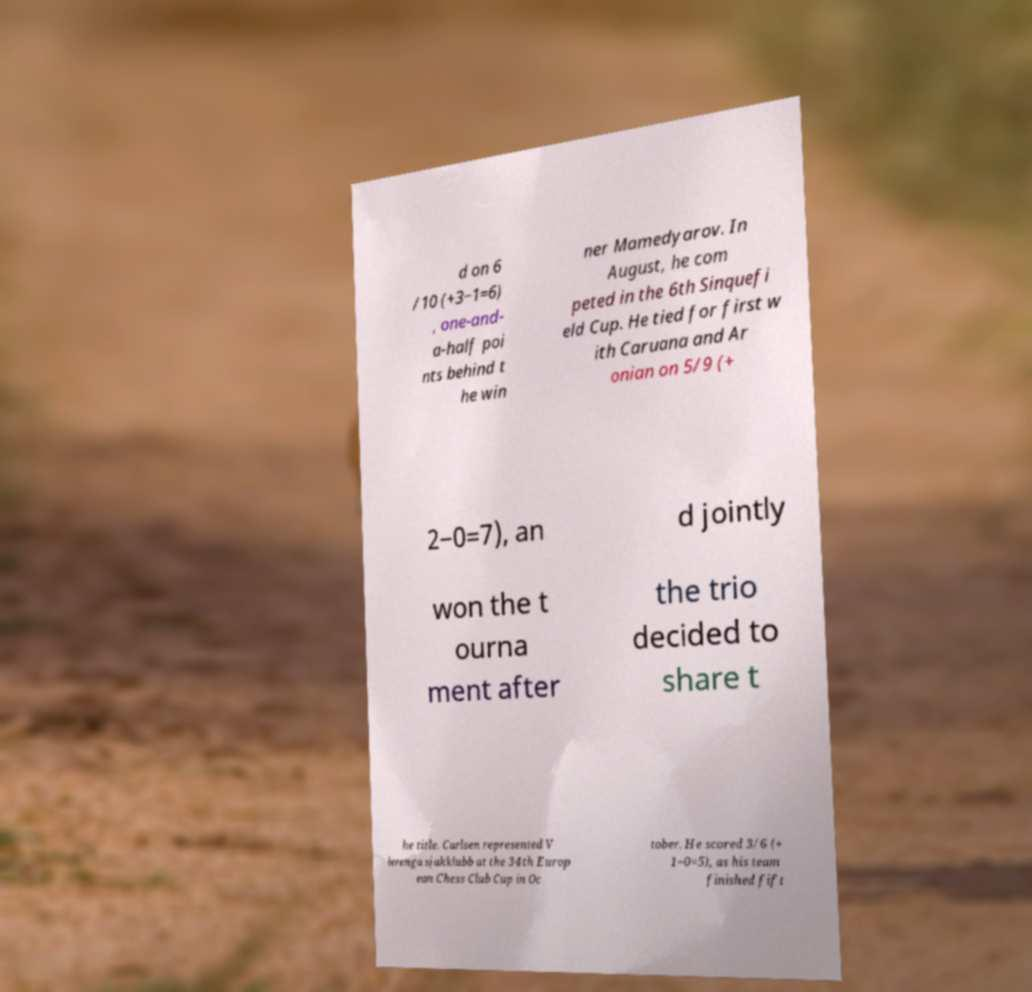What messages or text are displayed in this image? I need them in a readable, typed format. d on 6 /10 (+3−1=6) , one-and- a-half poi nts behind t he win ner Mamedyarov. In August, he com peted in the 6th Sinquefi eld Cup. He tied for first w ith Caruana and Ar onian on 5/9 (+ 2−0=7), an d jointly won the t ourna ment after the trio decided to share t he title. Carlsen represented V lerenga sjakklubb at the 34th Europ ean Chess Club Cup in Oc tober. He scored 3/6 (+ 1−0=5), as his team finished fift 